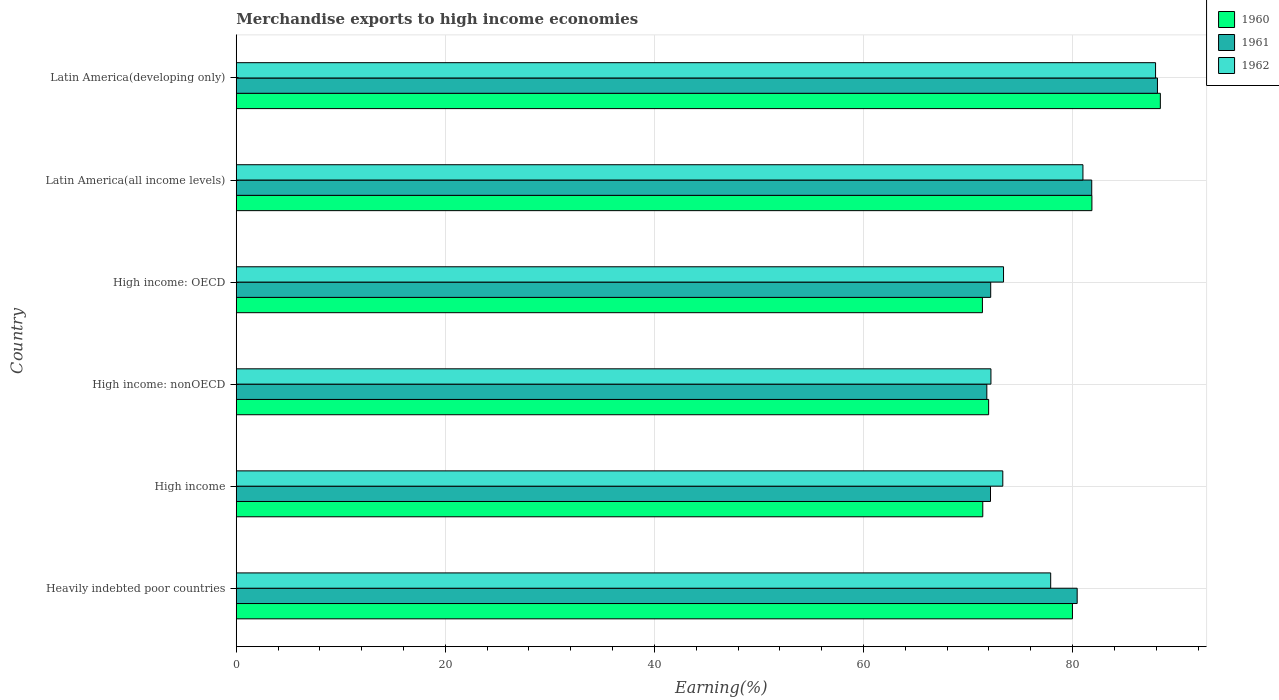How many different coloured bars are there?
Ensure brevity in your answer.  3. How many groups of bars are there?
Your response must be concise. 6. Are the number of bars per tick equal to the number of legend labels?
Give a very brief answer. Yes. Are the number of bars on each tick of the Y-axis equal?
Provide a short and direct response. Yes. How many bars are there on the 5th tick from the top?
Make the answer very short. 3. How many bars are there on the 2nd tick from the bottom?
Offer a very short reply. 3. What is the label of the 1st group of bars from the top?
Your response must be concise. Latin America(developing only). In how many cases, is the number of bars for a given country not equal to the number of legend labels?
Your response must be concise. 0. What is the percentage of amount earned from merchandise exports in 1962 in High income?
Provide a short and direct response. 73.33. Across all countries, what is the maximum percentage of amount earned from merchandise exports in 1960?
Offer a very short reply. 88.4. Across all countries, what is the minimum percentage of amount earned from merchandise exports in 1961?
Your answer should be very brief. 71.8. In which country was the percentage of amount earned from merchandise exports in 1961 maximum?
Make the answer very short. Latin America(developing only). In which country was the percentage of amount earned from merchandise exports in 1960 minimum?
Your response must be concise. High income: OECD. What is the total percentage of amount earned from merchandise exports in 1961 in the graph?
Provide a short and direct response. 466.51. What is the difference between the percentage of amount earned from merchandise exports in 1961 in Heavily indebted poor countries and that in Latin America(all income levels)?
Make the answer very short. -1.39. What is the difference between the percentage of amount earned from merchandise exports in 1961 in High income: OECD and the percentage of amount earned from merchandise exports in 1960 in High income?
Offer a terse response. 0.76. What is the average percentage of amount earned from merchandise exports in 1960 per country?
Your response must be concise. 77.5. What is the difference between the percentage of amount earned from merchandise exports in 1961 and percentage of amount earned from merchandise exports in 1962 in Heavily indebted poor countries?
Ensure brevity in your answer.  2.53. In how many countries, is the percentage of amount earned from merchandise exports in 1960 greater than 76 %?
Your response must be concise. 3. What is the ratio of the percentage of amount earned from merchandise exports in 1961 in High income to that in Latin America(all income levels)?
Provide a short and direct response. 0.88. Is the difference between the percentage of amount earned from merchandise exports in 1961 in Heavily indebted poor countries and High income greater than the difference between the percentage of amount earned from merchandise exports in 1962 in Heavily indebted poor countries and High income?
Provide a succinct answer. Yes. What is the difference between the highest and the second highest percentage of amount earned from merchandise exports in 1961?
Provide a short and direct response. 6.29. What is the difference between the highest and the lowest percentage of amount earned from merchandise exports in 1961?
Ensure brevity in your answer.  16.32. In how many countries, is the percentage of amount earned from merchandise exports in 1960 greater than the average percentage of amount earned from merchandise exports in 1960 taken over all countries?
Make the answer very short. 3. What does the 1st bar from the top in High income: OECD represents?
Provide a short and direct response. 1962. What does the 1st bar from the bottom in Latin America(all income levels) represents?
Ensure brevity in your answer.  1960. Is it the case that in every country, the sum of the percentage of amount earned from merchandise exports in 1960 and percentage of amount earned from merchandise exports in 1961 is greater than the percentage of amount earned from merchandise exports in 1962?
Make the answer very short. Yes. How many bars are there?
Provide a short and direct response. 18. What is the difference between two consecutive major ticks on the X-axis?
Give a very brief answer. 20. Does the graph contain any zero values?
Give a very brief answer. No. What is the title of the graph?
Your answer should be compact. Merchandise exports to high income economies. Does "1993" appear as one of the legend labels in the graph?
Offer a very short reply. No. What is the label or title of the X-axis?
Your response must be concise. Earning(%). What is the label or title of the Y-axis?
Offer a very short reply. Country. What is the Earning(%) of 1960 in Heavily indebted poor countries?
Offer a very short reply. 79.99. What is the Earning(%) of 1961 in Heavily indebted poor countries?
Give a very brief answer. 80.44. What is the Earning(%) in 1962 in Heavily indebted poor countries?
Ensure brevity in your answer.  77.91. What is the Earning(%) of 1960 in High income?
Your answer should be compact. 71.41. What is the Earning(%) of 1961 in High income?
Your answer should be very brief. 72.15. What is the Earning(%) of 1962 in High income?
Keep it short and to the point. 73.33. What is the Earning(%) in 1960 in High income: nonOECD?
Ensure brevity in your answer.  71.97. What is the Earning(%) in 1961 in High income: nonOECD?
Ensure brevity in your answer.  71.8. What is the Earning(%) of 1962 in High income: nonOECD?
Make the answer very short. 72.19. What is the Earning(%) in 1960 in High income: OECD?
Keep it short and to the point. 71.38. What is the Earning(%) in 1961 in High income: OECD?
Keep it short and to the point. 72.17. What is the Earning(%) in 1962 in High income: OECD?
Ensure brevity in your answer.  73.4. What is the Earning(%) of 1960 in Latin America(all income levels)?
Keep it short and to the point. 81.85. What is the Earning(%) in 1961 in Latin America(all income levels)?
Offer a terse response. 81.83. What is the Earning(%) in 1962 in Latin America(all income levels)?
Provide a succinct answer. 80.99. What is the Earning(%) of 1960 in Latin America(developing only)?
Offer a terse response. 88.4. What is the Earning(%) of 1961 in Latin America(developing only)?
Offer a terse response. 88.12. What is the Earning(%) of 1962 in Latin America(developing only)?
Keep it short and to the point. 87.94. Across all countries, what is the maximum Earning(%) of 1960?
Ensure brevity in your answer.  88.4. Across all countries, what is the maximum Earning(%) of 1961?
Provide a short and direct response. 88.12. Across all countries, what is the maximum Earning(%) of 1962?
Offer a terse response. 87.94. Across all countries, what is the minimum Earning(%) of 1960?
Offer a terse response. 71.38. Across all countries, what is the minimum Earning(%) of 1961?
Make the answer very short. 71.8. Across all countries, what is the minimum Earning(%) of 1962?
Your answer should be compact. 72.19. What is the total Earning(%) of 1960 in the graph?
Make the answer very short. 464.99. What is the total Earning(%) of 1961 in the graph?
Provide a short and direct response. 466.51. What is the total Earning(%) of 1962 in the graph?
Make the answer very short. 465.75. What is the difference between the Earning(%) in 1960 in Heavily indebted poor countries and that in High income?
Provide a succinct answer. 8.58. What is the difference between the Earning(%) of 1961 in Heavily indebted poor countries and that in High income?
Provide a succinct answer. 8.29. What is the difference between the Earning(%) of 1962 in Heavily indebted poor countries and that in High income?
Your answer should be compact. 4.58. What is the difference between the Earning(%) in 1960 in Heavily indebted poor countries and that in High income: nonOECD?
Your answer should be very brief. 8.02. What is the difference between the Earning(%) in 1961 in Heavily indebted poor countries and that in High income: nonOECD?
Your answer should be very brief. 8.64. What is the difference between the Earning(%) of 1962 in Heavily indebted poor countries and that in High income: nonOECD?
Provide a short and direct response. 5.71. What is the difference between the Earning(%) in 1960 in Heavily indebted poor countries and that in High income: OECD?
Give a very brief answer. 8.61. What is the difference between the Earning(%) in 1961 in Heavily indebted poor countries and that in High income: OECD?
Provide a short and direct response. 8.27. What is the difference between the Earning(%) of 1962 in Heavily indebted poor countries and that in High income: OECD?
Give a very brief answer. 4.51. What is the difference between the Earning(%) in 1960 in Heavily indebted poor countries and that in Latin America(all income levels)?
Provide a succinct answer. -1.86. What is the difference between the Earning(%) of 1961 in Heavily indebted poor countries and that in Latin America(all income levels)?
Your answer should be compact. -1.39. What is the difference between the Earning(%) in 1962 in Heavily indebted poor countries and that in Latin America(all income levels)?
Keep it short and to the point. -3.09. What is the difference between the Earning(%) of 1960 in Heavily indebted poor countries and that in Latin America(developing only)?
Keep it short and to the point. -8.41. What is the difference between the Earning(%) of 1961 in Heavily indebted poor countries and that in Latin America(developing only)?
Your answer should be compact. -7.68. What is the difference between the Earning(%) of 1962 in Heavily indebted poor countries and that in Latin America(developing only)?
Offer a terse response. -10.03. What is the difference between the Earning(%) in 1960 in High income and that in High income: nonOECD?
Keep it short and to the point. -0.56. What is the difference between the Earning(%) of 1961 in High income and that in High income: nonOECD?
Your answer should be very brief. 0.35. What is the difference between the Earning(%) in 1962 in High income and that in High income: nonOECD?
Offer a terse response. 1.14. What is the difference between the Earning(%) of 1960 in High income and that in High income: OECD?
Offer a very short reply. 0.04. What is the difference between the Earning(%) in 1961 in High income and that in High income: OECD?
Ensure brevity in your answer.  -0.02. What is the difference between the Earning(%) in 1962 in High income and that in High income: OECD?
Your answer should be very brief. -0.07. What is the difference between the Earning(%) in 1960 in High income and that in Latin America(all income levels)?
Your answer should be compact. -10.44. What is the difference between the Earning(%) of 1961 in High income and that in Latin America(all income levels)?
Give a very brief answer. -9.68. What is the difference between the Earning(%) in 1962 in High income and that in Latin America(all income levels)?
Keep it short and to the point. -7.67. What is the difference between the Earning(%) of 1960 in High income and that in Latin America(developing only)?
Ensure brevity in your answer.  -16.99. What is the difference between the Earning(%) in 1961 in High income and that in Latin America(developing only)?
Your answer should be very brief. -15.97. What is the difference between the Earning(%) of 1962 in High income and that in Latin America(developing only)?
Your response must be concise. -14.61. What is the difference between the Earning(%) in 1960 in High income: nonOECD and that in High income: OECD?
Ensure brevity in your answer.  0.59. What is the difference between the Earning(%) of 1961 in High income: nonOECD and that in High income: OECD?
Offer a terse response. -0.37. What is the difference between the Earning(%) of 1962 in High income: nonOECD and that in High income: OECD?
Give a very brief answer. -1.21. What is the difference between the Earning(%) in 1960 in High income: nonOECD and that in Latin America(all income levels)?
Provide a short and direct response. -9.88. What is the difference between the Earning(%) in 1961 in High income: nonOECD and that in Latin America(all income levels)?
Offer a terse response. -10.04. What is the difference between the Earning(%) of 1962 in High income: nonOECD and that in Latin America(all income levels)?
Your response must be concise. -8.8. What is the difference between the Earning(%) in 1960 in High income: nonOECD and that in Latin America(developing only)?
Provide a short and direct response. -16.43. What is the difference between the Earning(%) of 1961 in High income: nonOECD and that in Latin America(developing only)?
Your response must be concise. -16.32. What is the difference between the Earning(%) of 1962 in High income: nonOECD and that in Latin America(developing only)?
Your answer should be very brief. -15.75. What is the difference between the Earning(%) in 1960 in High income: OECD and that in Latin America(all income levels)?
Your response must be concise. -10.47. What is the difference between the Earning(%) in 1961 in High income: OECD and that in Latin America(all income levels)?
Your response must be concise. -9.67. What is the difference between the Earning(%) in 1962 in High income: OECD and that in Latin America(all income levels)?
Offer a terse response. -7.6. What is the difference between the Earning(%) in 1960 in High income: OECD and that in Latin America(developing only)?
Your answer should be compact. -17.02. What is the difference between the Earning(%) of 1961 in High income: OECD and that in Latin America(developing only)?
Give a very brief answer. -15.95. What is the difference between the Earning(%) in 1962 in High income: OECD and that in Latin America(developing only)?
Make the answer very short. -14.54. What is the difference between the Earning(%) of 1960 in Latin America(all income levels) and that in Latin America(developing only)?
Your response must be concise. -6.55. What is the difference between the Earning(%) of 1961 in Latin America(all income levels) and that in Latin America(developing only)?
Provide a short and direct response. -6.29. What is the difference between the Earning(%) in 1962 in Latin America(all income levels) and that in Latin America(developing only)?
Keep it short and to the point. -6.95. What is the difference between the Earning(%) in 1960 in Heavily indebted poor countries and the Earning(%) in 1961 in High income?
Give a very brief answer. 7.84. What is the difference between the Earning(%) in 1960 in Heavily indebted poor countries and the Earning(%) in 1962 in High income?
Your answer should be very brief. 6.66. What is the difference between the Earning(%) of 1961 in Heavily indebted poor countries and the Earning(%) of 1962 in High income?
Make the answer very short. 7.11. What is the difference between the Earning(%) in 1960 in Heavily indebted poor countries and the Earning(%) in 1961 in High income: nonOECD?
Make the answer very short. 8.19. What is the difference between the Earning(%) of 1960 in Heavily indebted poor countries and the Earning(%) of 1962 in High income: nonOECD?
Make the answer very short. 7.8. What is the difference between the Earning(%) in 1961 in Heavily indebted poor countries and the Earning(%) in 1962 in High income: nonOECD?
Provide a succinct answer. 8.25. What is the difference between the Earning(%) of 1960 in Heavily indebted poor countries and the Earning(%) of 1961 in High income: OECD?
Provide a succinct answer. 7.82. What is the difference between the Earning(%) of 1960 in Heavily indebted poor countries and the Earning(%) of 1962 in High income: OECD?
Your answer should be compact. 6.59. What is the difference between the Earning(%) of 1961 in Heavily indebted poor countries and the Earning(%) of 1962 in High income: OECD?
Offer a very short reply. 7.04. What is the difference between the Earning(%) of 1960 in Heavily indebted poor countries and the Earning(%) of 1961 in Latin America(all income levels)?
Make the answer very short. -1.84. What is the difference between the Earning(%) of 1960 in Heavily indebted poor countries and the Earning(%) of 1962 in Latin America(all income levels)?
Offer a very short reply. -1. What is the difference between the Earning(%) of 1961 in Heavily indebted poor countries and the Earning(%) of 1962 in Latin America(all income levels)?
Your answer should be compact. -0.55. What is the difference between the Earning(%) of 1960 in Heavily indebted poor countries and the Earning(%) of 1961 in Latin America(developing only)?
Your response must be concise. -8.13. What is the difference between the Earning(%) of 1960 in Heavily indebted poor countries and the Earning(%) of 1962 in Latin America(developing only)?
Your answer should be very brief. -7.95. What is the difference between the Earning(%) in 1961 in Heavily indebted poor countries and the Earning(%) in 1962 in Latin America(developing only)?
Offer a terse response. -7.5. What is the difference between the Earning(%) in 1960 in High income and the Earning(%) in 1961 in High income: nonOECD?
Your answer should be very brief. -0.39. What is the difference between the Earning(%) in 1960 in High income and the Earning(%) in 1962 in High income: nonOECD?
Your response must be concise. -0.78. What is the difference between the Earning(%) in 1961 in High income and the Earning(%) in 1962 in High income: nonOECD?
Provide a succinct answer. -0.04. What is the difference between the Earning(%) of 1960 in High income and the Earning(%) of 1961 in High income: OECD?
Offer a very short reply. -0.76. What is the difference between the Earning(%) in 1960 in High income and the Earning(%) in 1962 in High income: OECD?
Keep it short and to the point. -1.99. What is the difference between the Earning(%) in 1961 in High income and the Earning(%) in 1962 in High income: OECD?
Give a very brief answer. -1.25. What is the difference between the Earning(%) of 1960 in High income and the Earning(%) of 1961 in Latin America(all income levels)?
Make the answer very short. -10.42. What is the difference between the Earning(%) in 1960 in High income and the Earning(%) in 1962 in Latin America(all income levels)?
Your answer should be compact. -9.58. What is the difference between the Earning(%) of 1961 in High income and the Earning(%) of 1962 in Latin America(all income levels)?
Keep it short and to the point. -8.84. What is the difference between the Earning(%) in 1960 in High income and the Earning(%) in 1961 in Latin America(developing only)?
Ensure brevity in your answer.  -16.71. What is the difference between the Earning(%) in 1960 in High income and the Earning(%) in 1962 in Latin America(developing only)?
Give a very brief answer. -16.53. What is the difference between the Earning(%) of 1961 in High income and the Earning(%) of 1962 in Latin America(developing only)?
Keep it short and to the point. -15.79. What is the difference between the Earning(%) in 1960 in High income: nonOECD and the Earning(%) in 1961 in High income: OECD?
Keep it short and to the point. -0.2. What is the difference between the Earning(%) in 1960 in High income: nonOECD and the Earning(%) in 1962 in High income: OECD?
Make the answer very short. -1.43. What is the difference between the Earning(%) of 1961 in High income: nonOECD and the Earning(%) of 1962 in High income: OECD?
Provide a short and direct response. -1.6. What is the difference between the Earning(%) of 1960 in High income: nonOECD and the Earning(%) of 1961 in Latin America(all income levels)?
Your response must be concise. -9.86. What is the difference between the Earning(%) in 1960 in High income: nonOECD and the Earning(%) in 1962 in Latin America(all income levels)?
Your answer should be very brief. -9.02. What is the difference between the Earning(%) of 1961 in High income: nonOECD and the Earning(%) of 1962 in Latin America(all income levels)?
Offer a terse response. -9.19. What is the difference between the Earning(%) in 1960 in High income: nonOECD and the Earning(%) in 1961 in Latin America(developing only)?
Offer a terse response. -16.15. What is the difference between the Earning(%) in 1960 in High income: nonOECD and the Earning(%) in 1962 in Latin America(developing only)?
Offer a terse response. -15.97. What is the difference between the Earning(%) of 1961 in High income: nonOECD and the Earning(%) of 1962 in Latin America(developing only)?
Make the answer very short. -16.14. What is the difference between the Earning(%) of 1960 in High income: OECD and the Earning(%) of 1961 in Latin America(all income levels)?
Make the answer very short. -10.46. What is the difference between the Earning(%) in 1960 in High income: OECD and the Earning(%) in 1962 in Latin America(all income levels)?
Give a very brief answer. -9.62. What is the difference between the Earning(%) of 1961 in High income: OECD and the Earning(%) of 1962 in Latin America(all income levels)?
Make the answer very short. -8.82. What is the difference between the Earning(%) in 1960 in High income: OECD and the Earning(%) in 1961 in Latin America(developing only)?
Your answer should be very brief. -16.74. What is the difference between the Earning(%) in 1960 in High income: OECD and the Earning(%) in 1962 in Latin America(developing only)?
Keep it short and to the point. -16.56. What is the difference between the Earning(%) of 1961 in High income: OECD and the Earning(%) of 1962 in Latin America(developing only)?
Ensure brevity in your answer.  -15.77. What is the difference between the Earning(%) of 1960 in Latin America(all income levels) and the Earning(%) of 1961 in Latin America(developing only)?
Offer a very short reply. -6.27. What is the difference between the Earning(%) in 1960 in Latin America(all income levels) and the Earning(%) in 1962 in Latin America(developing only)?
Your answer should be very brief. -6.09. What is the difference between the Earning(%) of 1961 in Latin America(all income levels) and the Earning(%) of 1962 in Latin America(developing only)?
Your response must be concise. -6.11. What is the average Earning(%) in 1960 per country?
Your response must be concise. 77.5. What is the average Earning(%) of 1961 per country?
Offer a very short reply. 77.75. What is the average Earning(%) in 1962 per country?
Make the answer very short. 77.63. What is the difference between the Earning(%) of 1960 and Earning(%) of 1961 in Heavily indebted poor countries?
Give a very brief answer. -0.45. What is the difference between the Earning(%) in 1960 and Earning(%) in 1962 in Heavily indebted poor countries?
Your answer should be compact. 2.08. What is the difference between the Earning(%) in 1961 and Earning(%) in 1962 in Heavily indebted poor countries?
Offer a terse response. 2.53. What is the difference between the Earning(%) of 1960 and Earning(%) of 1961 in High income?
Keep it short and to the point. -0.74. What is the difference between the Earning(%) of 1960 and Earning(%) of 1962 in High income?
Keep it short and to the point. -1.92. What is the difference between the Earning(%) in 1961 and Earning(%) in 1962 in High income?
Give a very brief answer. -1.18. What is the difference between the Earning(%) in 1960 and Earning(%) in 1961 in High income: nonOECD?
Keep it short and to the point. 0.17. What is the difference between the Earning(%) of 1960 and Earning(%) of 1962 in High income: nonOECD?
Ensure brevity in your answer.  -0.22. What is the difference between the Earning(%) in 1961 and Earning(%) in 1962 in High income: nonOECD?
Offer a terse response. -0.39. What is the difference between the Earning(%) in 1960 and Earning(%) in 1961 in High income: OECD?
Offer a very short reply. -0.79. What is the difference between the Earning(%) of 1960 and Earning(%) of 1962 in High income: OECD?
Offer a terse response. -2.02. What is the difference between the Earning(%) of 1961 and Earning(%) of 1962 in High income: OECD?
Keep it short and to the point. -1.23. What is the difference between the Earning(%) of 1960 and Earning(%) of 1961 in Latin America(all income levels)?
Provide a short and direct response. 0.02. What is the difference between the Earning(%) in 1960 and Earning(%) in 1962 in Latin America(all income levels)?
Your response must be concise. 0.86. What is the difference between the Earning(%) of 1961 and Earning(%) of 1962 in Latin America(all income levels)?
Ensure brevity in your answer.  0.84. What is the difference between the Earning(%) in 1960 and Earning(%) in 1961 in Latin America(developing only)?
Provide a succinct answer. 0.28. What is the difference between the Earning(%) of 1960 and Earning(%) of 1962 in Latin America(developing only)?
Your answer should be compact. 0.46. What is the difference between the Earning(%) of 1961 and Earning(%) of 1962 in Latin America(developing only)?
Ensure brevity in your answer.  0.18. What is the ratio of the Earning(%) in 1960 in Heavily indebted poor countries to that in High income?
Make the answer very short. 1.12. What is the ratio of the Earning(%) of 1961 in Heavily indebted poor countries to that in High income?
Give a very brief answer. 1.11. What is the ratio of the Earning(%) in 1962 in Heavily indebted poor countries to that in High income?
Provide a short and direct response. 1.06. What is the ratio of the Earning(%) in 1960 in Heavily indebted poor countries to that in High income: nonOECD?
Keep it short and to the point. 1.11. What is the ratio of the Earning(%) of 1961 in Heavily indebted poor countries to that in High income: nonOECD?
Offer a terse response. 1.12. What is the ratio of the Earning(%) of 1962 in Heavily indebted poor countries to that in High income: nonOECD?
Your answer should be compact. 1.08. What is the ratio of the Earning(%) in 1960 in Heavily indebted poor countries to that in High income: OECD?
Your response must be concise. 1.12. What is the ratio of the Earning(%) of 1961 in Heavily indebted poor countries to that in High income: OECD?
Offer a terse response. 1.11. What is the ratio of the Earning(%) in 1962 in Heavily indebted poor countries to that in High income: OECD?
Your response must be concise. 1.06. What is the ratio of the Earning(%) in 1960 in Heavily indebted poor countries to that in Latin America(all income levels)?
Ensure brevity in your answer.  0.98. What is the ratio of the Earning(%) in 1962 in Heavily indebted poor countries to that in Latin America(all income levels)?
Your response must be concise. 0.96. What is the ratio of the Earning(%) in 1960 in Heavily indebted poor countries to that in Latin America(developing only)?
Ensure brevity in your answer.  0.9. What is the ratio of the Earning(%) of 1961 in Heavily indebted poor countries to that in Latin America(developing only)?
Provide a short and direct response. 0.91. What is the ratio of the Earning(%) in 1962 in Heavily indebted poor countries to that in Latin America(developing only)?
Your answer should be very brief. 0.89. What is the ratio of the Earning(%) in 1961 in High income to that in High income: nonOECD?
Provide a succinct answer. 1. What is the ratio of the Earning(%) in 1962 in High income to that in High income: nonOECD?
Offer a terse response. 1.02. What is the ratio of the Earning(%) of 1961 in High income to that in High income: OECD?
Provide a succinct answer. 1. What is the ratio of the Earning(%) of 1962 in High income to that in High income: OECD?
Your answer should be very brief. 1. What is the ratio of the Earning(%) in 1960 in High income to that in Latin America(all income levels)?
Give a very brief answer. 0.87. What is the ratio of the Earning(%) of 1961 in High income to that in Latin America(all income levels)?
Offer a terse response. 0.88. What is the ratio of the Earning(%) of 1962 in High income to that in Latin America(all income levels)?
Give a very brief answer. 0.91. What is the ratio of the Earning(%) in 1960 in High income to that in Latin America(developing only)?
Your answer should be compact. 0.81. What is the ratio of the Earning(%) in 1961 in High income to that in Latin America(developing only)?
Your answer should be very brief. 0.82. What is the ratio of the Earning(%) of 1962 in High income to that in Latin America(developing only)?
Ensure brevity in your answer.  0.83. What is the ratio of the Earning(%) of 1960 in High income: nonOECD to that in High income: OECD?
Provide a short and direct response. 1.01. What is the ratio of the Earning(%) of 1961 in High income: nonOECD to that in High income: OECD?
Your response must be concise. 0.99. What is the ratio of the Earning(%) in 1962 in High income: nonOECD to that in High income: OECD?
Offer a terse response. 0.98. What is the ratio of the Earning(%) in 1960 in High income: nonOECD to that in Latin America(all income levels)?
Keep it short and to the point. 0.88. What is the ratio of the Earning(%) in 1961 in High income: nonOECD to that in Latin America(all income levels)?
Your answer should be very brief. 0.88. What is the ratio of the Earning(%) of 1962 in High income: nonOECD to that in Latin America(all income levels)?
Make the answer very short. 0.89. What is the ratio of the Earning(%) in 1960 in High income: nonOECD to that in Latin America(developing only)?
Your response must be concise. 0.81. What is the ratio of the Earning(%) of 1961 in High income: nonOECD to that in Latin America(developing only)?
Ensure brevity in your answer.  0.81. What is the ratio of the Earning(%) in 1962 in High income: nonOECD to that in Latin America(developing only)?
Offer a very short reply. 0.82. What is the ratio of the Earning(%) in 1960 in High income: OECD to that in Latin America(all income levels)?
Provide a succinct answer. 0.87. What is the ratio of the Earning(%) in 1961 in High income: OECD to that in Latin America(all income levels)?
Offer a very short reply. 0.88. What is the ratio of the Earning(%) of 1962 in High income: OECD to that in Latin America(all income levels)?
Provide a succinct answer. 0.91. What is the ratio of the Earning(%) in 1960 in High income: OECD to that in Latin America(developing only)?
Make the answer very short. 0.81. What is the ratio of the Earning(%) of 1961 in High income: OECD to that in Latin America(developing only)?
Ensure brevity in your answer.  0.82. What is the ratio of the Earning(%) in 1962 in High income: OECD to that in Latin America(developing only)?
Provide a succinct answer. 0.83. What is the ratio of the Earning(%) in 1960 in Latin America(all income levels) to that in Latin America(developing only)?
Offer a very short reply. 0.93. What is the ratio of the Earning(%) of 1961 in Latin America(all income levels) to that in Latin America(developing only)?
Keep it short and to the point. 0.93. What is the ratio of the Earning(%) of 1962 in Latin America(all income levels) to that in Latin America(developing only)?
Offer a very short reply. 0.92. What is the difference between the highest and the second highest Earning(%) in 1960?
Your answer should be compact. 6.55. What is the difference between the highest and the second highest Earning(%) of 1961?
Provide a succinct answer. 6.29. What is the difference between the highest and the second highest Earning(%) of 1962?
Make the answer very short. 6.95. What is the difference between the highest and the lowest Earning(%) of 1960?
Keep it short and to the point. 17.02. What is the difference between the highest and the lowest Earning(%) of 1961?
Provide a succinct answer. 16.32. What is the difference between the highest and the lowest Earning(%) in 1962?
Provide a succinct answer. 15.75. 